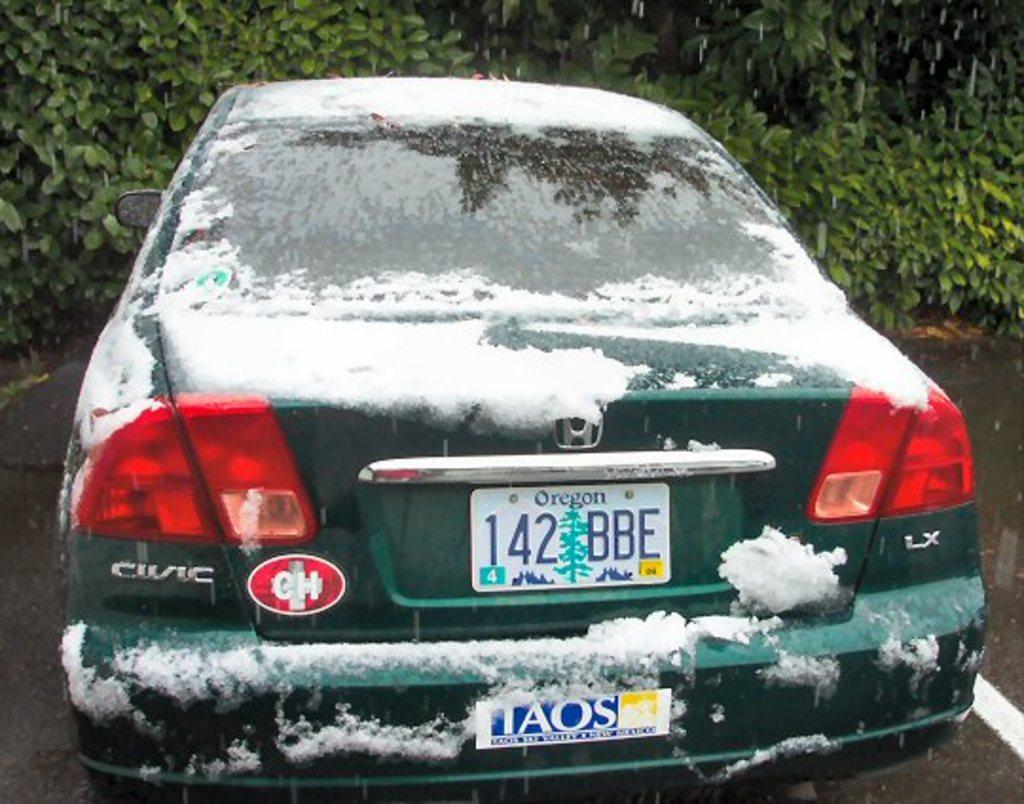<image>
Write a terse but informative summary of the picture. A green Civic from Oregon has snow on it. 